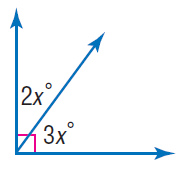Question: Find x.
Choices:
A. 18
B. 27
C. 36
D. 72
Answer with the letter. Answer: A 